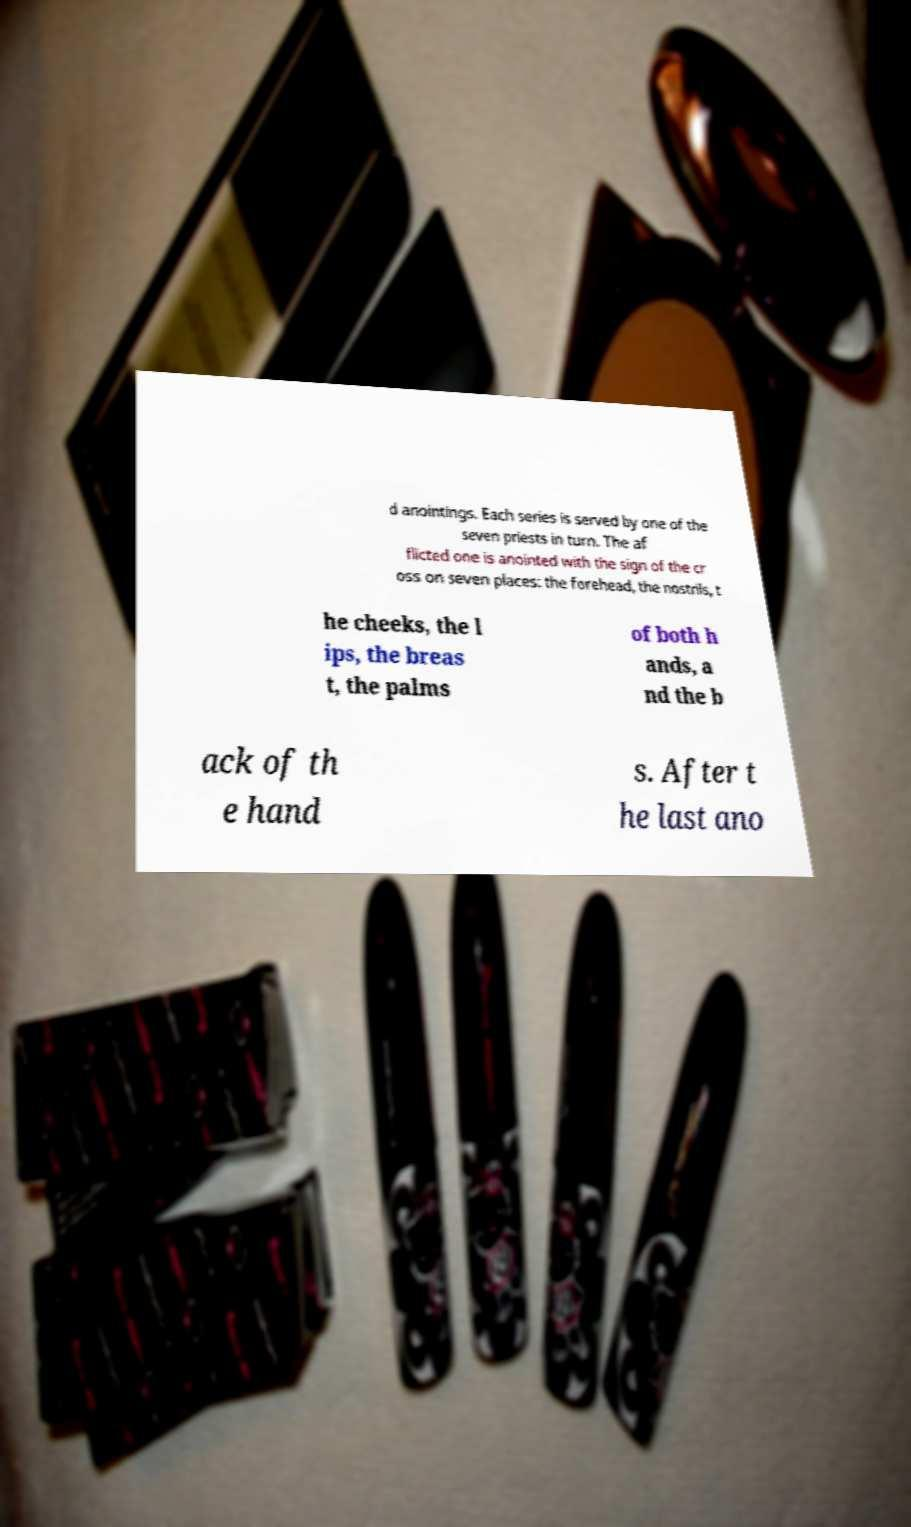Could you assist in decoding the text presented in this image and type it out clearly? d anointings. Each series is served by one of the seven priests in turn. The af flicted one is anointed with the sign of the cr oss on seven places: the forehead, the nostrils, t he cheeks, the l ips, the breas t, the palms of both h ands, a nd the b ack of th e hand s. After t he last ano 